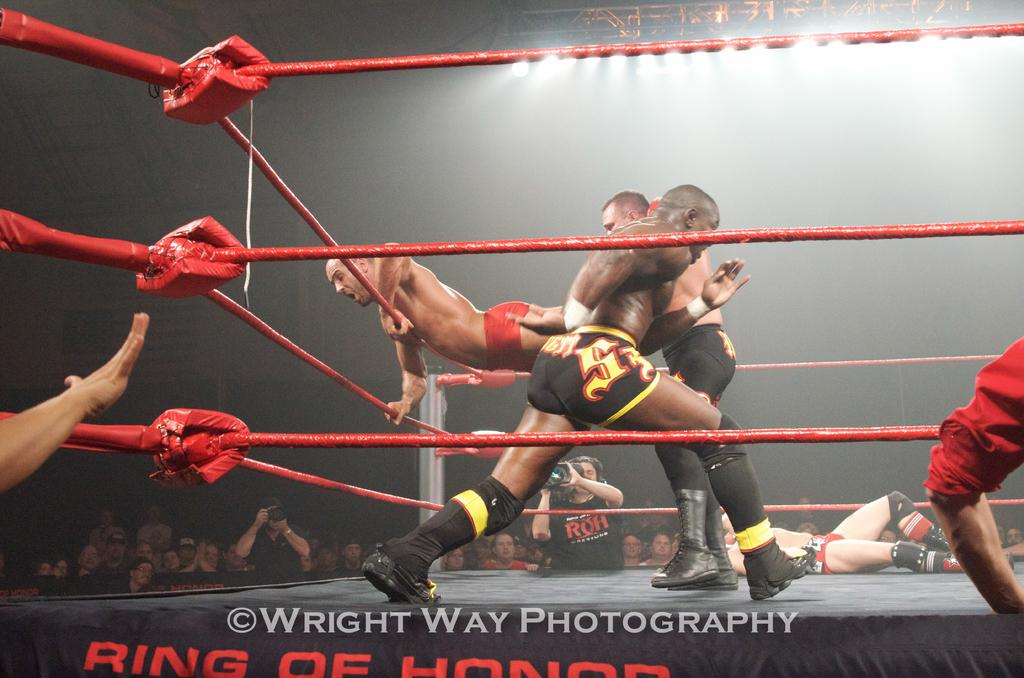<image>
Create a compact narrative representing the image presented. A photograph of four wrestlers in a ring by Wright Way Photography. 